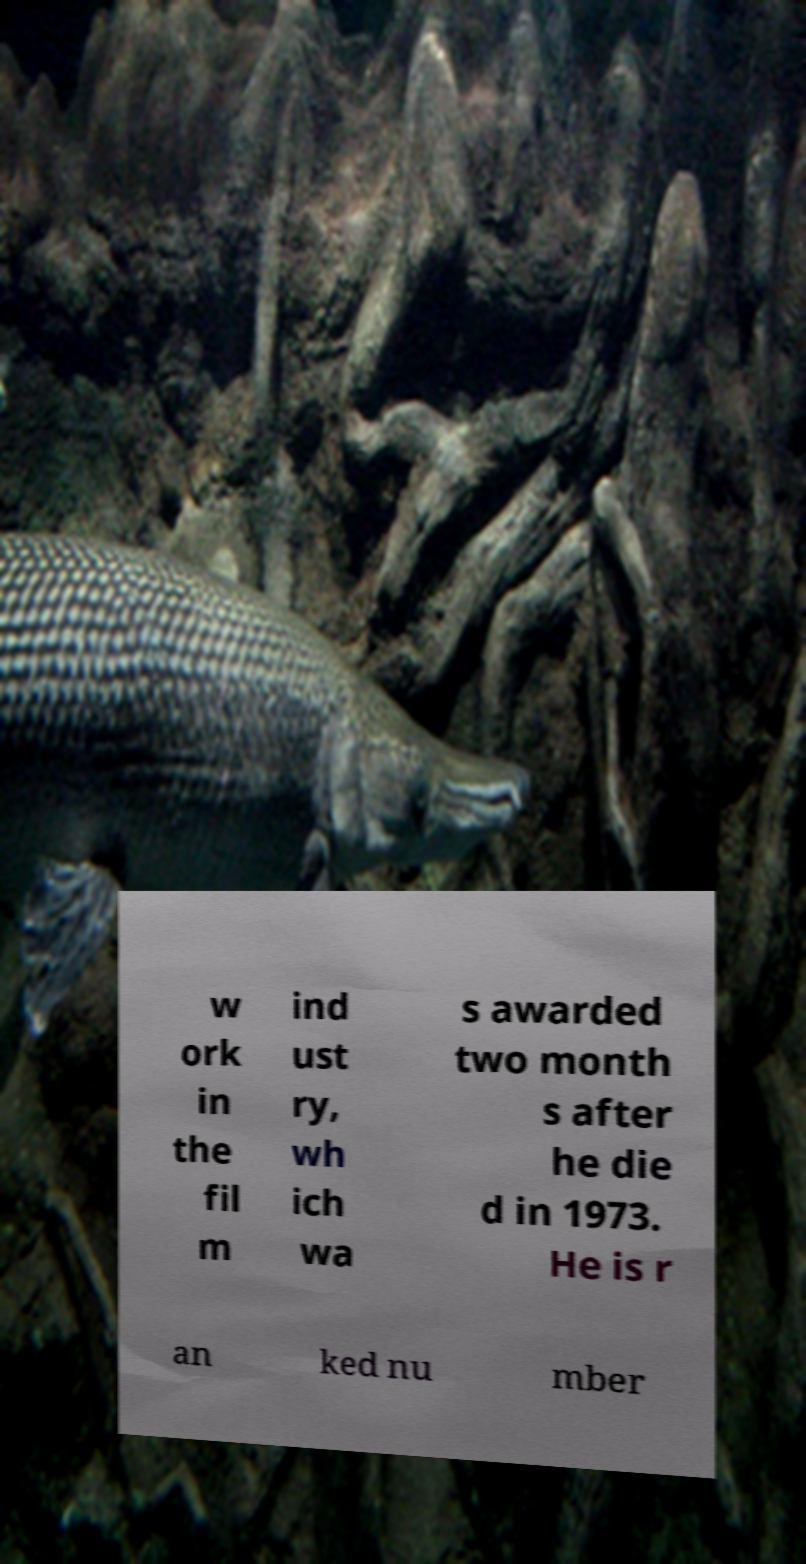Could you assist in decoding the text presented in this image and type it out clearly? w ork in the fil m ind ust ry, wh ich wa s awarded two month s after he die d in 1973. He is r an ked nu mber 